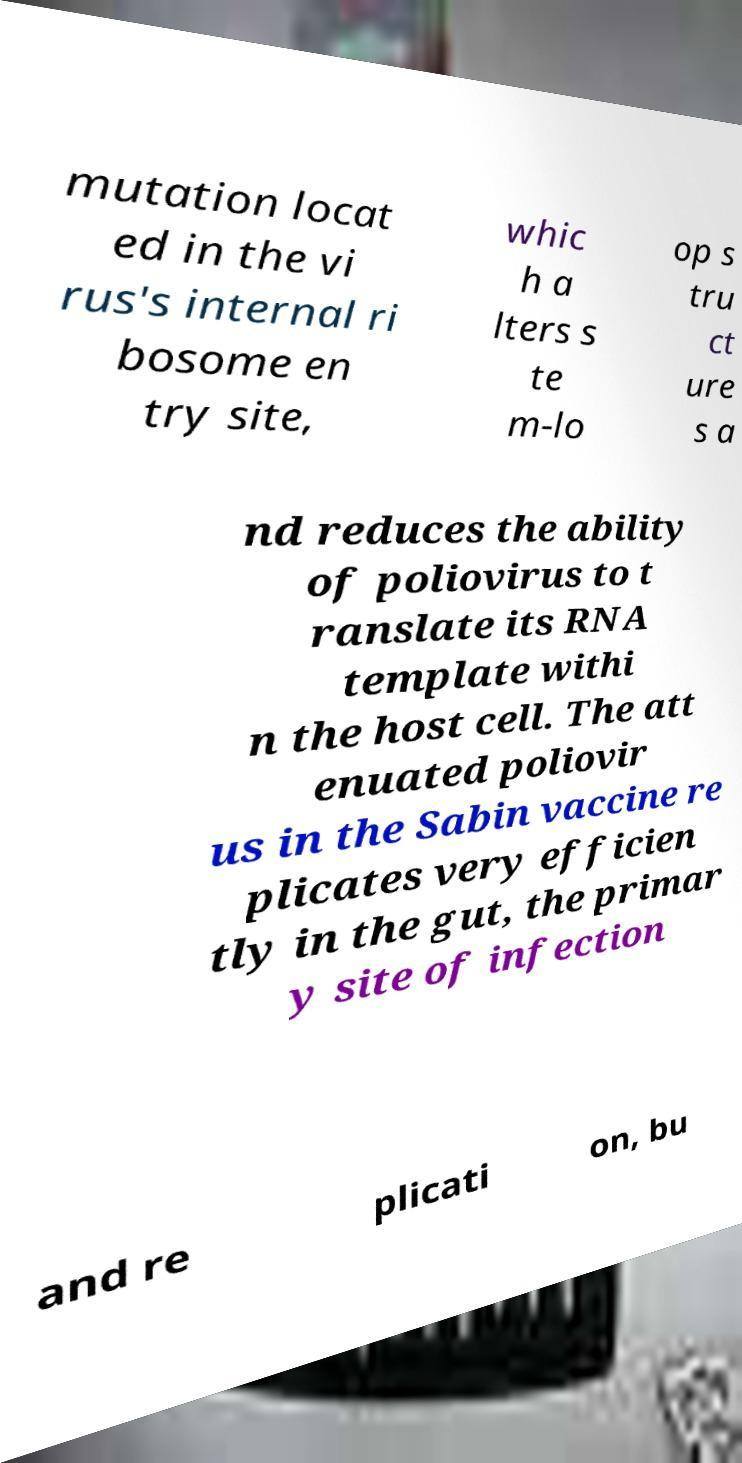Please identify and transcribe the text found in this image. mutation locat ed in the vi rus's internal ri bosome en try site, whic h a lters s te m-lo op s tru ct ure s a nd reduces the ability of poliovirus to t ranslate its RNA template withi n the host cell. The att enuated poliovir us in the Sabin vaccine re plicates very efficien tly in the gut, the primar y site of infection and re plicati on, bu 